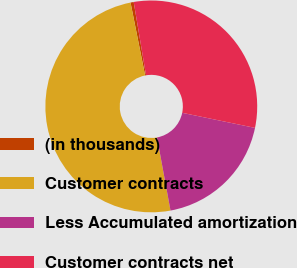<chart> <loc_0><loc_0><loc_500><loc_500><pie_chart><fcel>(in thousands)<fcel>Customer contracts<fcel>Less Accumulated amortization<fcel>Customer contracts net<nl><fcel>0.48%<fcel>49.76%<fcel>18.85%<fcel>30.91%<nl></chart> 